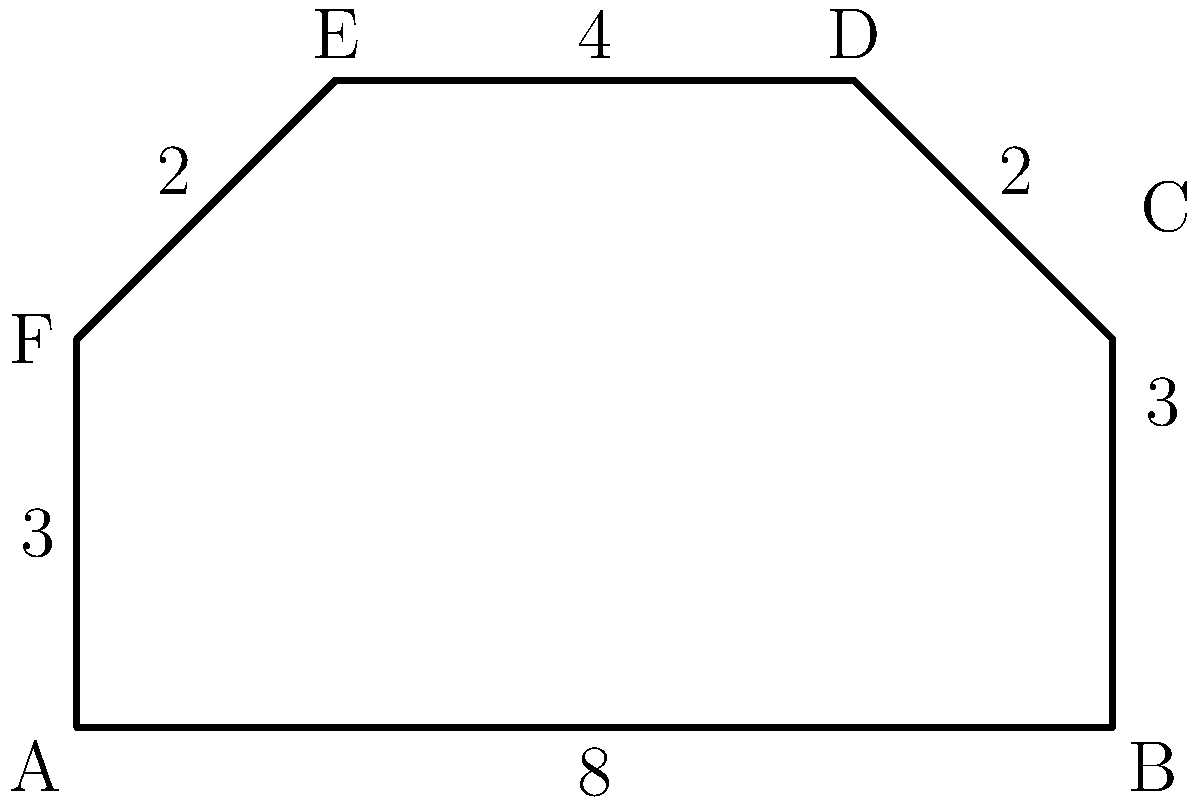Your latest vinyl pressing needs a custom-designed vintage synthesizer case. The outline of the synth is represented by the irregular hexagon shown above. Calculate the perimeter of this groovy shape to determine how much eco-friendly reclaimed wood you'll need for the edge trim. All measurements are in decameters (dam). Let's break this down step-by-step, just like dissecting the layers of a complex shoegaze track:

1) We need to sum up the lengths of all sides of the hexagon:

   Side AB: 8 dam
   Side BC: 3 dam
   Side CD: 2 dam
   Side DE: 4 dam
   Side EF: 2 dam
   Side FA: 3 dam

2) Now, let's add these up:

   $$ \text{Perimeter} = 8 + 3 + 2 + 4 + 2 + 3 $$

3) Simplifying:

   $$ \text{Perimeter} = 22 \text{ dam} $$

So, you'll need 22 decameters of reclaimed wood to trim the edge of your vintage synth case. That's 220 meters of pure analog aesthetic!
Answer: 22 dam 